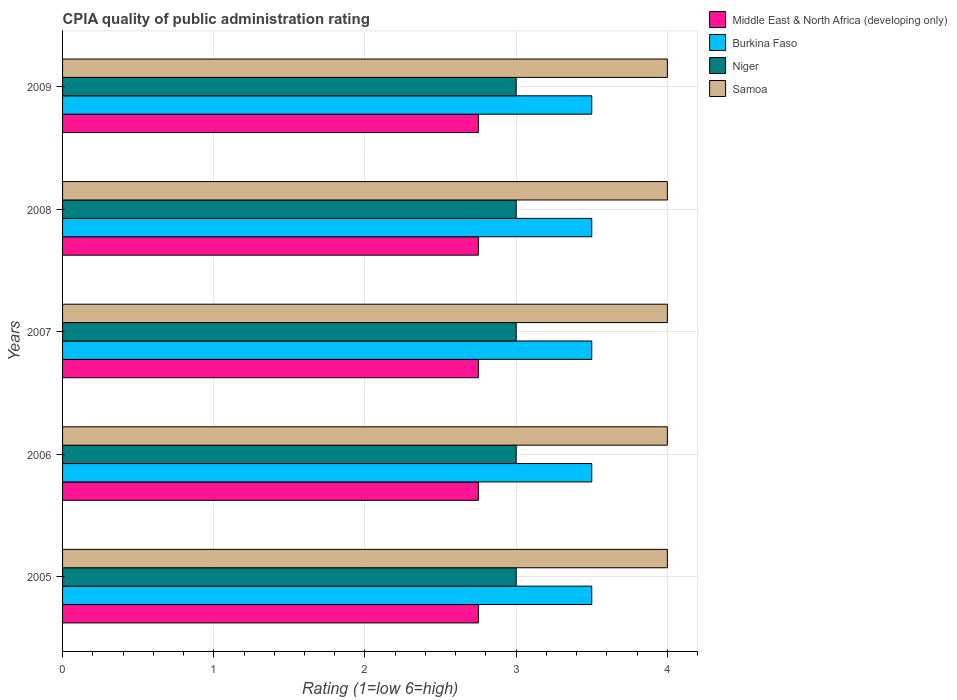How many different coloured bars are there?
Your response must be concise. 4. Are the number of bars per tick equal to the number of legend labels?
Your answer should be very brief. Yes. Are the number of bars on each tick of the Y-axis equal?
Your answer should be very brief. Yes. How many bars are there on the 1st tick from the top?
Ensure brevity in your answer.  4. In how many cases, is the number of bars for a given year not equal to the number of legend labels?
Offer a very short reply. 0. What is the CPIA rating in Middle East & North Africa (developing only) in 2007?
Offer a terse response. 2.75. Across all years, what is the maximum CPIA rating in Niger?
Keep it short and to the point. 3. Across all years, what is the minimum CPIA rating in Niger?
Your answer should be compact. 3. What is the total CPIA rating in Middle East & North Africa (developing only) in the graph?
Make the answer very short. 13.75. What is the difference between the CPIA rating in Middle East & North Africa (developing only) in 2005 and the CPIA rating in Burkina Faso in 2007?
Provide a short and direct response. -0.75. What is the average CPIA rating in Niger per year?
Your response must be concise. 3. In the year 2006, what is the difference between the CPIA rating in Samoa and CPIA rating in Niger?
Your answer should be very brief. 1. Is the CPIA rating in Samoa in 2007 less than that in 2008?
Your answer should be compact. No. Is the difference between the CPIA rating in Samoa in 2005 and 2009 greater than the difference between the CPIA rating in Niger in 2005 and 2009?
Give a very brief answer. No. What is the difference between the highest and the second highest CPIA rating in Niger?
Provide a succinct answer. 0. In how many years, is the CPIA rating in Niger greater than the average CPIA rating in Niger taken over all years?
Ensure brevity in your answer.  0. Is the sum of the CPIA rating in Middle East & North Africa (developing only) in 2006 and 2007 greater than the maximum CPIA rating in Burkina Faso across all years?
Your answer should be very brief. Yes. Is it the case that in every year, the sum of the CPIA rating in Samoa and CPIA rating in Niger is greater than the sum of CPIA rating in Middle East & North Africa (developing only) and CPIA rating in Burkina Faso?
Offer a terse response. Yes. What does the 4th bar from the top in 2007 represents?
Your response must be concise. Middle East & North Africa (developing only). What does the 1st bar from the bottom in 2007 represents?
Provide a short and direct response. Middle East & North Africa (developing only). Are all the bars in the graph horizontal?
Ensure brevity in your answer.  Yes. What is the difference between two consecutive major ticks on the X-axis?
Give a very brief answer. 1. Are the values on the major ticks of X-axis written in scientific E-notation?
Provide a succinct answer. No. Where does the legend appear in the graph?
Keep it short and to the point. Top right. How are the legend labels stacked?
Provide a short and direct response. Vertical. What is the title of the graph?
Offer a very short reply. CPIA quality of public administration rating. Does "Faeroe Islands" appear as one of the legend labels in the graph?
Offer a terse response. No. What is the label or title of the X-axis?
Ensure brevity in your answer.  Rating (1=low 6=high). What is the label or title of the Y-axis?
Your response must be concise. Years. What is the Rating (1=low 6=high) of Middle East & North Africa (developing only) in 2005?
Provide a succinct answer. 2.75. What is the Rating (1=low 6=high) of Middle East & North Africa (developing only) in 2006?
Provide a succinct answer. 2.75. What is the Rating (1=low 6=high) in Middle East & North Africa (developing only) in 2007?
Offer a terse response. 2.75. What is the Rating (1=low 6=high) of Burkina Faso in 2007?
Keep it short and to the point. 3.5. What is the Rating (1=low 6=high) in Middle East & North Africa (developing only) in 2008?
Provide a succinct answer. 2.75. What is the Rating (1=low 6=high) of Burkina Faso in 2008?
Make the answer very short. 3.5. What is the Rating (1=low 6=high) of Niger in 2008?
Ensure brevity in your answer.  3. What is the Rating (1=low 6=high) in Samoa in 2008?
Keep it short and to the point. 4. What is the Rating (1=low 6=high) in Middle East & North Africa (developing only) in 2009?
Your answer should be compact. 2.75. What is the Rating (1=low 6=high) of Niger in 2009?
Your answer should be very brief. 3. What is the Rating (1=low 6=high) in Samoa in 2009?
Ensure brevity in your answer.  4. Across all years, what is the maximum Rating (1=low 6=high) in Middle East & North Africa (developing only)?
Give a very brief answer. 2.75. Across all years, what is the maximum Rating (1=low 6=high) of Burkina Faso?
Your response must be concise. 3.5. Across all years, what is the maximum Rating (1=low 6=high) in Niger?
Offer a very short reply. 3. Across all years, what is the maximum Rating (1=low 6=high) of Samoa?
Provide a short and direct response. 4. Across all years, what is the minimum Rating (1=low 6=high) of Middle East & North Africa (developing only)?
Give a very brief answer. 2.75. Across all years, what is the minimum Rating (1=low 6=high) of Burkina Faso?
Ensure brevity in your answer.  3.5. Across all years, what is the minimum Rating (1=low 6=high) of Samoa?
Your answer should be very brief. 4. What is the total Rating (1=low 6=high) of Middle East & North Africa (developing only) in the graph?
Give a very brief answer. 13.75. What is the total Rating (1=low 6=high) in Burkina Faso in the graph?
Provide a succinct answer. 17.5. What is the total Rating (1=low 6=high) of Niger in the graph?
Ensure brevity in your answer.  15. What is the total Rating (1=low 6=high) in Samoa in the graph?
Provide a succinct answer. 20. What is the difference between the Rating (1=low 6=high) in Middle East & North Africa (developing only) in 2005 and that in 2006?
Make the answer very short. 0. What is the difference between the Rating (1=low 6=high) in Burkina Faso in 2005 and that in 2006?
Make the answer very short. 0. What is the difference between the Rating (1=low 6=high) in Niger in 2005 and that in 2006?
Your answer should be very brief. 0. What is the difference between the Rating (1=low 6=high) in Middle East & North Africa (developing only) in 2005 and that in 2008?
Offer a very short reply. 0. What is the difference between the Rating (1=low 6=high) of Niger in 2005 and that in 2008?
Provide a short and direct response. 0. What is the difference between the Rating (1=low 6=high) in Samoa in 2005 and that in 2008?
Give a very brief answer. 0. What is the difference between the Rating (1=low 6=high) in Middle East & North Africa (developing only) in 2005 and that in 2009?
Keep it short and to the point. 0. What is the difference between the Rating (1=low 6=high) in Samoa in 2005 and that in 2009?
Make the answer very short. 0. What is the difference between the Rating (1=low 6=high) of Samoa in 2006 and that in 2007?
Provide a succinct answer. 0. What is the difference between the Rating (1=low 6=high) of Middle East & North Africa (developing only) in 2006 and that in 2008?
Provide a short and direct response. 0. What is the difference between the Rating (1=low 6=high) of Niger in 2006 and that in 2009?
Keep it short and to the point. 0. What is the difference between the Rating (1=low 6=high) of Samoa in 2006 and that in 2009?
Make the answer very short. 0. What is the difference between the Rating (1=low 6=high) in Middle East & North Africa (developing only) in 2007 and that in 2008?
Give a very brief answer. 0. What is the difference between the Rating (1=low 6=high) in Burkina Faso in 2007 and that in 2008?
Provide a succinct answer. 0. What is the difference between the Rating (1=low 6=high) of Niger in 2007 and that in 2008?
Provide a succinct answer. 0. What is the difference between the Rating (1=low 6=high) of Middle East & North Africa (developing only) in 2007 and that in 2009?
Offer a terse response. 0. What is the difference between the Rating (1=low 6=high) of Burkina Faso in 2007 and that in 2009?
Keep it short and to the point. 0. What is the difference between the Rating (1=low 6=high) in Niger in 2007 and that in 2009?
Ensure brevity in your answer.  0. What is the difference between the Rating (1=low 6=high) in Niger in 2008 and that in 2009?
Give a very brief answer. 0. What is the difference between the Rating (1=low 6=high) in Samoa in 2008 and that in 2009?
Provide a succinct answer. 0. What is the difference between the Rating (1=low 6=high) in Middle East & North Africa (developing only) in 2005 and the Rating (1=low 6=high) in Burkina Faso in 2006?
Make the answer very short. -0.75. What is the difference between the Rating (1=low 6=high) of Middle East & North Africa (developing only) in 2005 and the Rating (1=low 6=high) of Niger in 2006?
Provide a succinct answer. -0.25. What is the difference between the Rating (1=low 6=high) of Middle East & North Africa (developing only) in 2005 and the Rating (1=low 6=high) of Samoa in 2006?
Offer a very short reply. -1.25. What is the difference between the Rating (1=low 6=high) in Burkina Faso in 2005 and the Rating (1=low 6=high) in Niger in 2006?
Provide a short and direct response. 0.5. What is the difference between the Rating (1=low 6=high) in Burkina Faso in 2005 and the Rating (1=low 6=high) in Samoa in 2006?
Your answer should be compact. -0.5. What is the difference between the Rating (1=low 6=high) in Niger in 2005 and the Rating (1=low 6=high) in Samoa in 2006?
Offer a terse response. -1. What is the difference between the Rating (1=low 6=high) in Middle East & North Africa (developing only) in 2005 and the Rating (1=low 6=high) in Burkina Faso in 2007?
Your response must be concise. -0.75. What is the difference between the Rating (1=low 6=high) of Middle East & North Africa (developing only) in 2005 and the Rating (1=low 6=high) of Samoa in 2007?
Your response must be concise. -1.25. What is the difference between the Rating (1=low 6=high) in Niger in 2005 and the Rating (1=low 6=high) in Samoa in 2007?
Make the answer very short. -1. What is the difference between the Rating (1=low 6=high) of Middle East & North Africa (developing only) in 2005 and the Rating (1=low 6=high) of Burkina Faso in 2008?
Provide a short and direct response. -0.75. What is the difference between the Rating (1=low 6=high) in Middle East & North Africa (developing only) in 2005 and the Rating (1=low 6=high) in Samoa in 2008?
Make the answer very short. -1.25. What is the difference between the Rating (1=low 6=high) of Burkina Faso in 2005 and the Rating (1=low 6=high) of Samoa in 2008?
Ensure brevity in your answer.  -0.5. What is the difference between the Rating (1=low 6=high) in Niger in 2005 and the Rating (1=low 6=high) in Samoa in 2008?
Offer a very short reply. -1. What is the difference between the Rating (1=low 6=high) of Middle East & North Africa (developing only) in 2005 and the Rating (1=low 6=high) of Burkina Faso in 2009?
Your answer should be very brief. -0.75. What is the difference between the Rating (1=low 6=high) in Middle East & North Africa (developing only) in 2005 and the Rating (1=low 6=high) in Samoa in 2009?
Your response must be concise. -1.25. What is the difference between the Rating (1=low 6=high) of Burkina Faso in 2005 and the Rating (1=low 6=high) of Samoa in 2009?
Offer a terse response. -0.5. What is the difference between the Rating (1=low 6=high) of Niger in 2005 and the Rating (1=low 6=high) of Samoa in 2009?
Offer a terse response. -1. What is the difference between the Rating (1=low 6=high) in Middle East & North Africa (developing only) in 2006 and the Rating (1=low 6=high) in Burkina Faso in 2007?
Your answer should be compact. -0.75. What is the difference between the Rating (1=low 6=high) in Middle East & North Africa (developing only) in 2006 and the Rating (1=low 6=high) in Samoa in 2007?
Provide a short and direct response. -1.25. What is the difference between the Rating (1=low 6=high) in Burkina Faso in 2006 and the Rating (1=low 6=high) in Niger in 2007?
Your answer should be very brief. 0.5. What is the difference between the Rating (1=low 6=high) of Burkina Faso in 2006 and the Rating (1=low 6=high) of Samoa in 2007?
Provide a succinct answer. -0.5. What is the difference between the Rating (1=low 6=high) in Middle East & North Africa (developing only) in 2006 and the Rating (1=low 6=high) in Burkina Faso in 2008?
Your answer should be compact. -0.75. What is the difference between the Rating (1=low 6=high) of Middle East & North Africa (developing only) in 2006 and the Rating (1=low 6=high) of Niger in 2008?
Ensure brevity in your answer.  -0.25. What is the difference between the Rating (1=low 6=high) of Middle East & North Africa (developing only) in 2006 and the Rating (1=low 6=high) of Samoa in 2008?
Offer a very short reply. -1.25. What is the difference between the Rating (1=low 6=high) of Burkina Faso in 2006 and the Rating (1=low 6=high) of Samoa in 2008?
Provide a short and direct response. -0.5. What is the difference between the Rating (1=low 6=high) in Middle East & North Africa (developing only) in 2006 and the Rating (1=low 6=high) in Burkina Faso in 2009?
Your response must be concise. -0.75. What is the difference between the Rating (1=low 6=high) in Middle East & North Africa (developing only) in 2006 and the Rating (1=low 6=high) in Niger in 2009?
Provide a short and direct response. -0.25. What is the difference between the Rating (1=low 6=high) of Middle East & North Africa (developing only) in 2006 and the Rating (1=low 6=high) of Samoa in 2009?
Make the answer very short. -1.25. What is the difference between the Rating (1=low 6=high) of Burkina Faso in 2006 and the Rating (1=low 6=high) of Niger in 2009?
Ensure brevity in your answer.  0.5. What is the difference between the Rating (1=low 6=high) in Niger in 2006 and the Rating (1=low 6=high) in Samoa in 2009?
Your answer should be very brief. -1. What is the difference between the Rating (1=low 6=high) in Middle East & North Africa (developing only) in 2007 and the Rating (1=low 6=high) in Burkina Faso in 2008?
Offer a terse response. -0.75. What is the difference between the Rating (1=low 6=high) in Middle East & North Africa (developing only) in 2007 and the Rating (1=low 6=high) in Samoa in 2008?
Offer a very short reply. -1.25. What is the difference between the Rating (1=low 6=high) of Niger in 2007 and the Rating (1=low 6=high) of Samoa in 2008?
Provide a succinct answer. -1. What is the difference between the Rating (1=low 6=high) in Middle East & North Africa (developing only) in 2007 and the Rating (1=low 6=high) in Burkina Faso in 2009?
Offer a very short reply. -0.75. What is the difference between the Rating (1=low 6=high) in Middle East & North Africa (developing only) in 2007 and the Rating (1=low 6=high) in Samoa in 2009?
Your answer should be very brief. -1.25. What is the difference between the Rating (1=low 6=high) in Burkina Faso in 2007 and the Rating (1=low 6=high) in Niger in 2009?
Your answer should be very brief. 0.5. What is the difference between the Rating (1=low 6=high) of Burkina Faso in 2007 and the Rating (1=low 6=high) of Samoa in 2009?
Your answer should be compact. -0.5. What is the difference between the Rating (1=low 6=high) in Middle East & North Africa (developing only) in 2008 and the Rating (1=low 6=high) in Burkina Faso in 2009?
Give a very brief answer. -0.75. What is the difference between the Rating (1=low 6=high) of Middle East & North Africa (developing only) in 2008 and the Rating (1=low 6=high) of Niger in 2009?
Provide a short and direct response. -0.25. What is the difference between the Rating (1=low 6=high) of Middle East & North Africa (developing only) in 2008 and the Rating (1=low 6=high) of Samoa in 2009?
Provide a short and direct response. -1.25. What is the difference between the Rating (1=low 6=high) in Niger in 2008 and the Rating (1=low 6=high) in Samoa in 2009?
Your answer should be compact. -1. What is the average Rating (1=low 6=high) of Middle East & North Africa (developing only) per year?
Your answer should be very brief. 2.75. What is the average Rating (1=low 6=high) of Niger per year?
Ensure brevity in your answer.  3. What is the average Rating (1=low 6=high) in Samoa per year?
Your response must be concise. 4. In the year 2005, what is the difference between the Rating (1=low 6=high) in Middle East & North Africa (developing only) and Rating (1=low 6=high) in Burkina Faso?
Your answer should be compact. -0.75. In the year 2005, what is the difference between the Rating (1=low 6=high) in Middle East & North Africa (developing only) and Rating (1=low 6=high) in Niger?
Make the answer very short. -0.25. In the year 2005, what is the difference between the Rating (1=low 6=high) in Middle East & North Africa (developing only) and Rating (1=low 6=high) in Samoa?
Give a very brief answer. -1.25. In the year 2005, what is the difference between the Rating (1=low 6=high) in Niger and Rating (1=low 6=high) in Samoa?
Ensure brevity in your answer.  -1. In the year 2006, what is the difference between the Rating (1=low 6=high) of Middle East & North Africa (developing only) and Rating (1=low 6=high) of Burkina Faso?
Provide a succinct answer. -0.75. In the year 2006, what is the difference between the Rating (1=low 6=high) in Middle East & North Africa (developing only) and Rating (1=low 6=high) in Niger?
Ensure brevity in your answer.  -0.25. In the year 2006, what is the difference between the Rating (1=low 6=high) of Middle East & North Africa (developing only) and Rating (1=low 6=high) of Samoa?
Provide a short and direct response. -1.25. In the year 2006, what is the difference between the Rating (1=low 6=high) in Niger and Rating (1=low 6=high) in Samoa?
Keep it short and to the point. -1. In the year 2007, what is the difference between the Rating (1=low 6=high) in Middle East & North Africa (developing only) and Rating (1=low 6=high) in Burkina Faso?
Keep it short and to the point. -0.75. In the year 2007, what is the difference between the Rating (1=low 6=high) of Middle East & North Africa (developing only) and Rating (1=low 6=high) of Samoa?
Offer a very short reply. -1.25. In the year 2007, what is the difference between the Rating (1=low 6=high) in Burkina Faso and Rating (1=low 6=high) in Niger?
Offer a terse response. 0.5. In the year 2007, what is the difference between the Rating (1=low 6=high) of Niger and Rating (1=low 6=high) of Samoa?
Keep it short and to the point. -1. In the year 2008, what is the difference between the Rating (1=low 6=high) of Middle East & North Africa (developing only) and Rating (1=low 6=high) of Burkina Faso?
Make the answer very short. -0.75. In the year 2008, what is the difference between the Rating (1=low 6=high) in Middle East & North Africa (developing only) and Rating (1=low 6=high) in Samoa?
Your response must be concise. -1.25. In the year 2008, what is the difference between the Rating (1=low 6=high) of Niger and Rating (1=low 6=high) of Samoa?
Your response must be concise. -1. In the year 2009, what is the difference between the Rating (1=low 6=high) of Middle East & North Africa (developing only) and Rating (1=low 6=high) of Burkina Faso?
Your response must be concise. -0.75. In the year 2009, what is the difference between the Rating (1=low 6=high) of Middle East & North Africa (developing only) and Rating (1=low 6=high) of Niger?
Your answer should be compact. -0.25. In the year 2009, what is the difference between the Rating (1=low 6=high) of Middle East & North Africa (developing only) and Rating (1=low 6=high) of Samoa?
Your answer should be compact. -1.25. In the year 2009, what is the difference between the Rating (1=low 6=high) in Burkina Faso and Rating (1=low 6=high) in Niger?
Your answer should be very brief. 0.5. In the year 2009, what is the difference between the Rating (1=low 6=high) of Niger and Rating (1=low 6=high) of Samoa?
Ensure brevity in your answer.  -1. What is the ratio of the Rating (1=low 6=high) in Burkina Faso in 2005 to that in 2007?
Your response must be concise. 1. What is the ratio of the Rating (1=low 6=high) in Niger in 2005 to that in 2007?
Keep it short and to the point. 1. What is the ratio of the Rating (1=low 6=high) of Middle East & North Africa (developing only) in 2005 to that in 2008?
Your response must be concise. 1. What is the ratio of the Rating (1=low 6=high) in Burkina Faso in 2005 to that in 2008?
Your answer should be compact. 1. What is the ratio of the Rating (1=low 6=high) of Niger in 2005 to that in 2008?
Offer a terse response. 1. What is the ratio of the Rating (1=low 6=high) of Middle East & North Africa (developing only) in 2005 to that in 2009?
Give a very brief answer. 1. What is the ratio of the Rating (1=low 6=high) in Middle East & North Africa (developing only) in 2006 to that in 2007?
Make the answer very short. 1. What is the ratio of the Rating (1=low 6=high) of Samoa in 2006 to that in 2008?
Provide a succinct answer. 1. What is the ratio of the Rating (1=low 6=high) of Middle East & North Africa (developing only) in 2006 to that in 2009?
Ensure brevity in your answer.  1. What is the ratio of the Rating (1=low 6=high) in Samoa in 2006 to that in 2009?
Ensure brevity in your answer.  1. What is the ratio of the Rating (1=low 6=high) of Middle East & North Africa (developing only) in 2007 to that in 2008?
Your response must be concise. 1. What is the ratio of the Rating (1=low 6=high) in Niger in 2007 to that in 2008?
Ensure brevity in your answer.  1. What is the ratio of the Rating (1=low 6=high) of Samoa in 2007 to that in 2008?
Keep it short and to the point. 1. What is the ratio of the Rating (1=low 6=high) in Middle East & North Africa (developing only) in 2007 to that in 2009?
Make the answer very short. 1. What is the ratio of the Rating (1=low 6=high) in Middle East & North Africa (developing only) in 2008 to that in 2009?
Keep it short and to the point. 1. What is the ratio of the Rating (1=low 6=high) in Burkina Faso in 2008 to that in 2009?
Offer a terse response. 1. What is the ratio of the Rating (1=low 6=high) in Niger in 2008 to that in 2009?
Offer a very short reply. 1. What is the ratio of the Rating (1=low 6=high) in Samoa in 2008 to that in 2009?
Offer a very short reply. 1. What is the difference between the highest and the second highest Rating (1=low 6=high) in Middle East & North Africa (developing only)?
Your response must be concise. 0. What is the difference between the highest and the second highest Rating (1=low 6=high) of Burkina Faso?
Provide a short and direct response. 0. What is the difference between the highest and the lowest Rating (1=low 6=high) of Middle East & North Africa (developing only)?
Offer a very short reply. 0. What is the difference between the highest and the lowest Rating (1=low 6=high) of Burkina Faso?
Keep it short and to the point. 0. What is the difference between the highest and the lowest Rating (1=low 6=high) of Samoa?
Offer a very short reply. 0. 